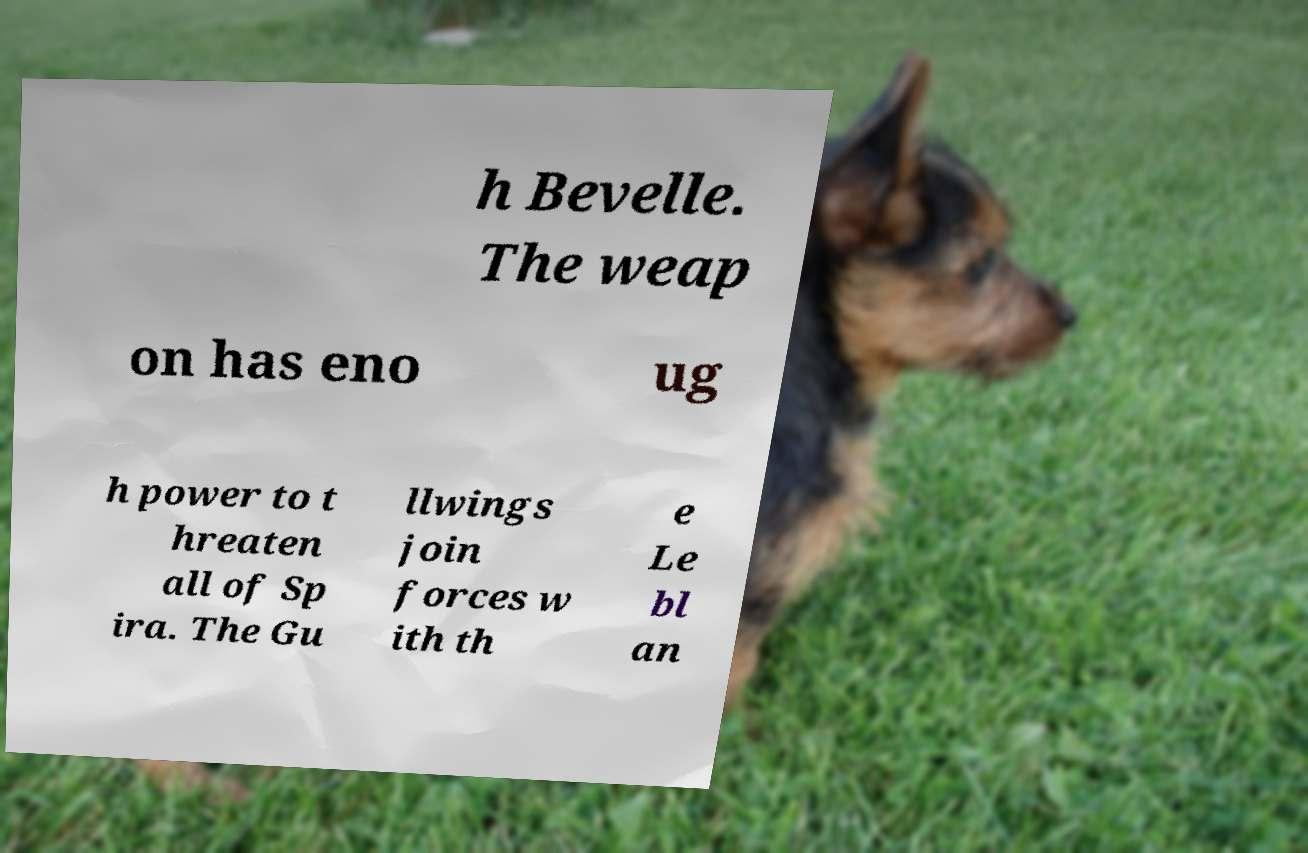Please identify and transcribe the text found in this image. h Bevelle. The weap on has eno ug h power to t hreaten all of Sp ira. The Gu llwings join forces w ith th e Le bl an 